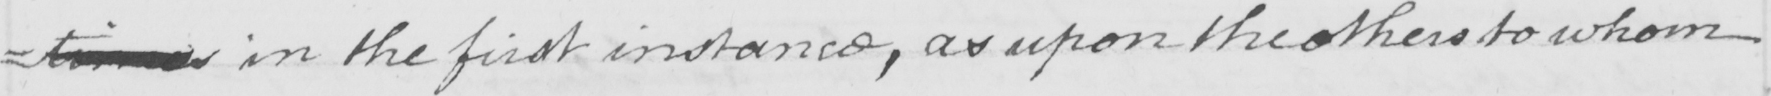What text is written in this handwritten line? =timesin the first instance , as upon the others to whom 